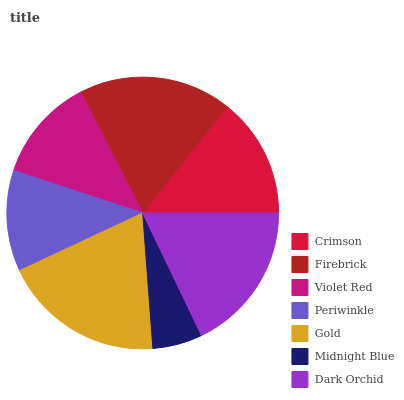Is Midnight Blue the minimum?
Answer yes or no. Yes. Is Gold the maximum?
Answer yes or no. Yes. Is Firebrick the minimum?
Answer yes or no. No. Is Firebrick the maximum?
Answer yes or no. No. Is Firebrick greater than Crimson?
Answer yes or no. Yes. Is Crimson less than Firebrick?
Answer yes or no. Yes. Is Crimson greater than Firebrick?
Answer yes or no. No. Is Firebrick less than Crimson?
Answer yes or no. No. Is Crimson the high median?
Answer yes or no. Yes. Is Crimson the low median?
Answer yes or no. Yes. Is Periwinkle the high median?
Answer yes or no. No. Is Periwinkle the low median?
Answer yes or no. No. 